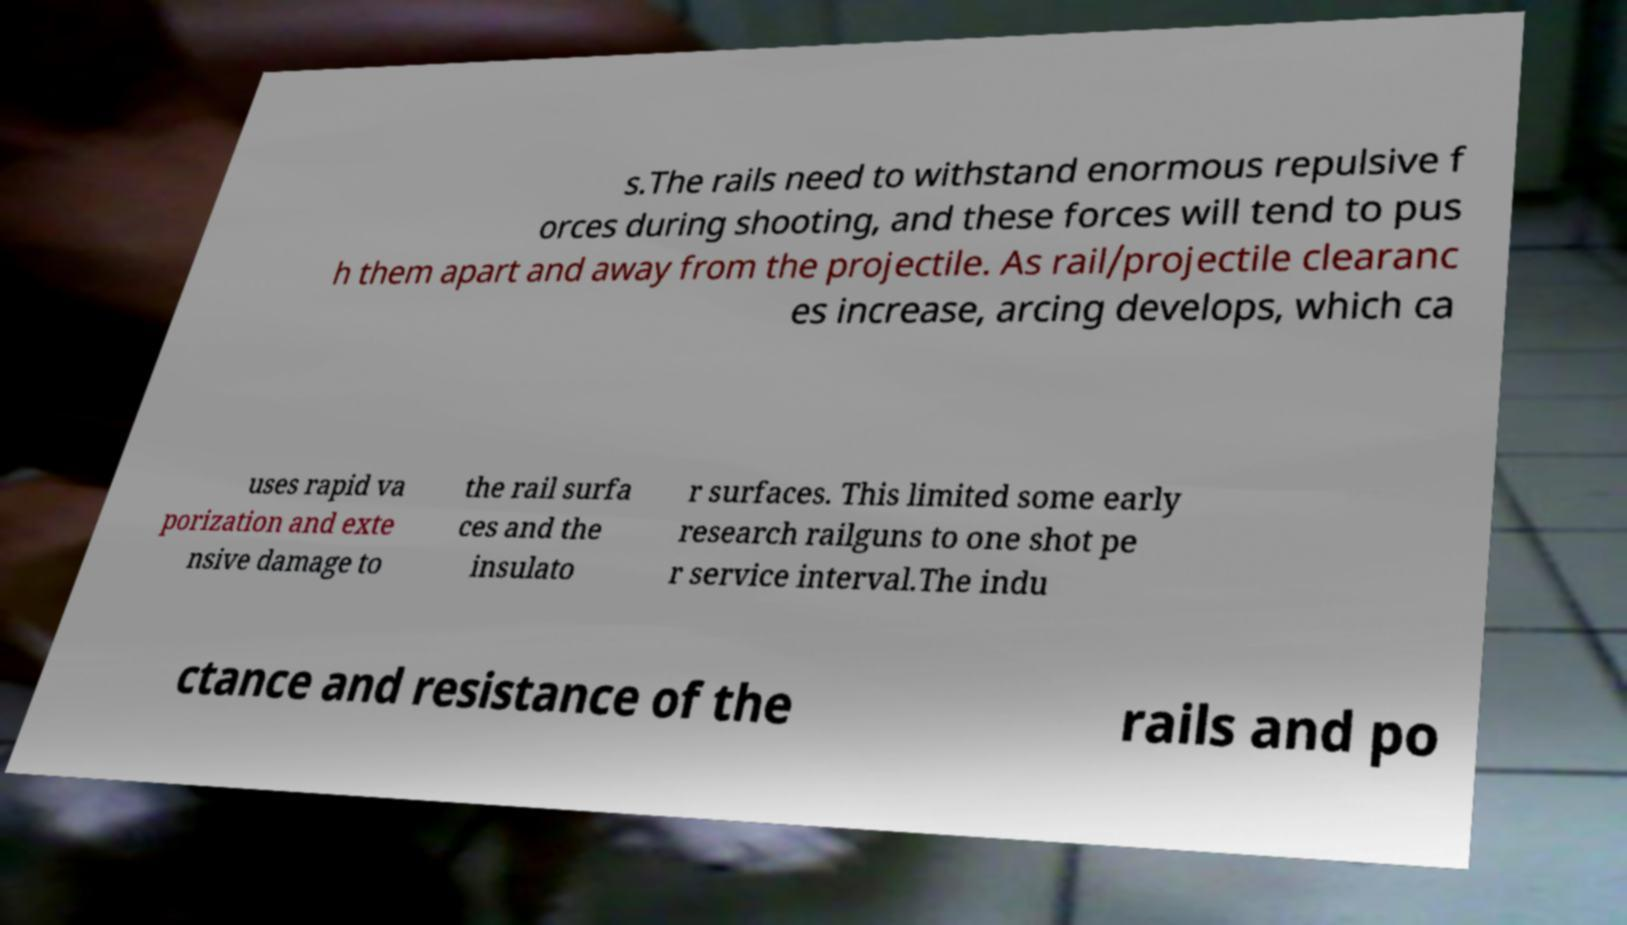What messages or text are displayed in this image? I need them in a readable, typed format. s.The rails need to withstand enormous repulsive f orces during shooting, and these forces will tend to pus h them apart and away from the projectile. As rail/projectile clearanc es increase, arcing develops, which ca uses rapid va porization and exte nsive damage to the rail surfa ces and the insulato r surfaces. This limited some early research railguns to one shot pe r service interval.The indu ctance and resistance of the rails and po 